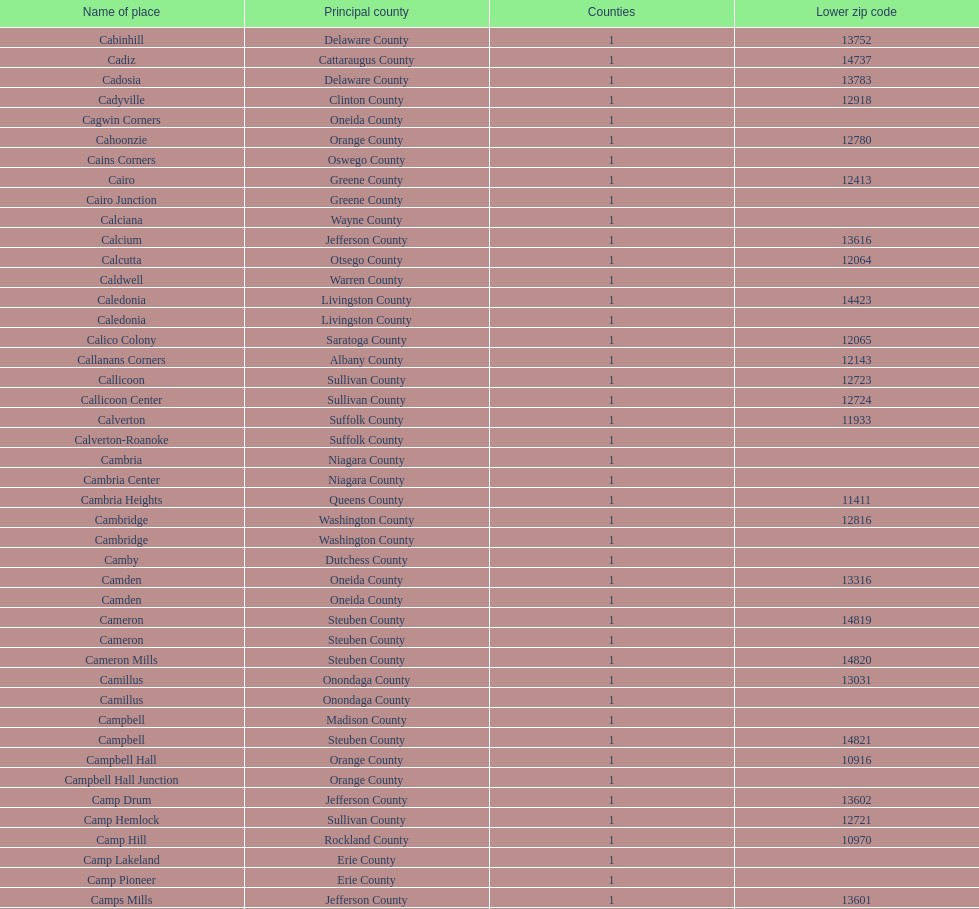How many total places are in greene county? 10. 